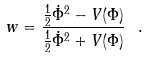Convert formula to latex. <formula><loc_0><loc_0><loc_500><loc_500>w = \frac { \frac { 1 } { 2 } \dot { \Phi } ^ { 2 } - V ( \Phi ) } { \frac { 1 } { 2 } \dot { \Phi } ^ { 2 } + V ( \Phi ) } \ .</formula> 